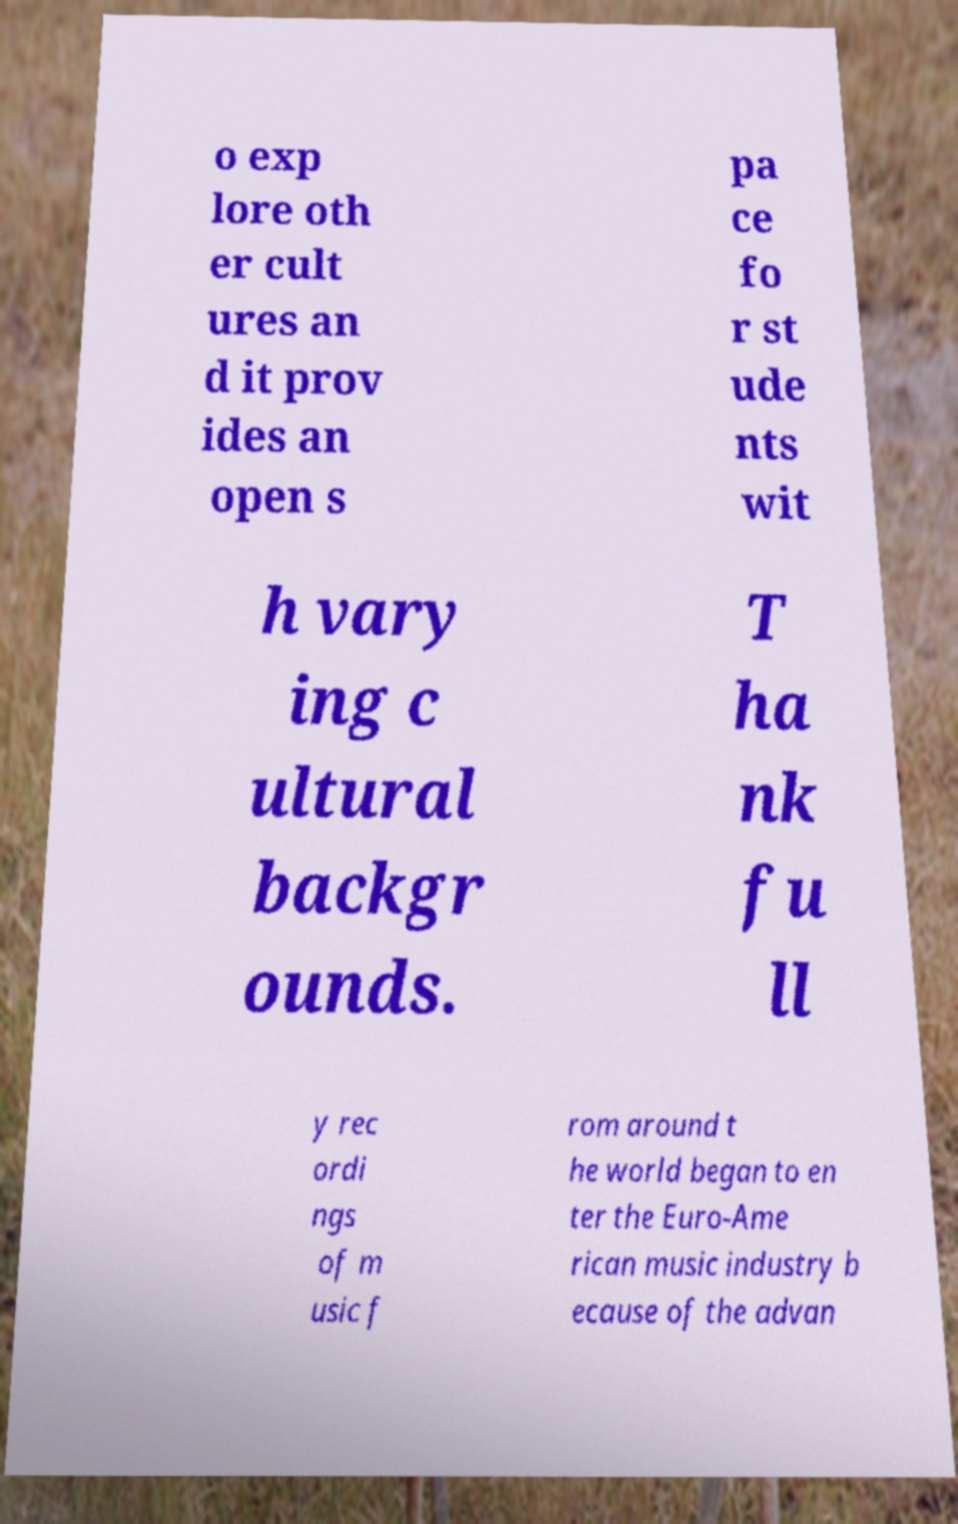Please read and relay the text visible in this image. What does it say? o exp lore oth er cult ures an d it prov ides an open s pa ce fo r st ude nts wit h vary ing c ultural backgr ounds. T ha nk fu ll y rec ordi ngs of m usic f rom around t he world began to en ter the Euro-Ame rican music industry b ecause of the advan 